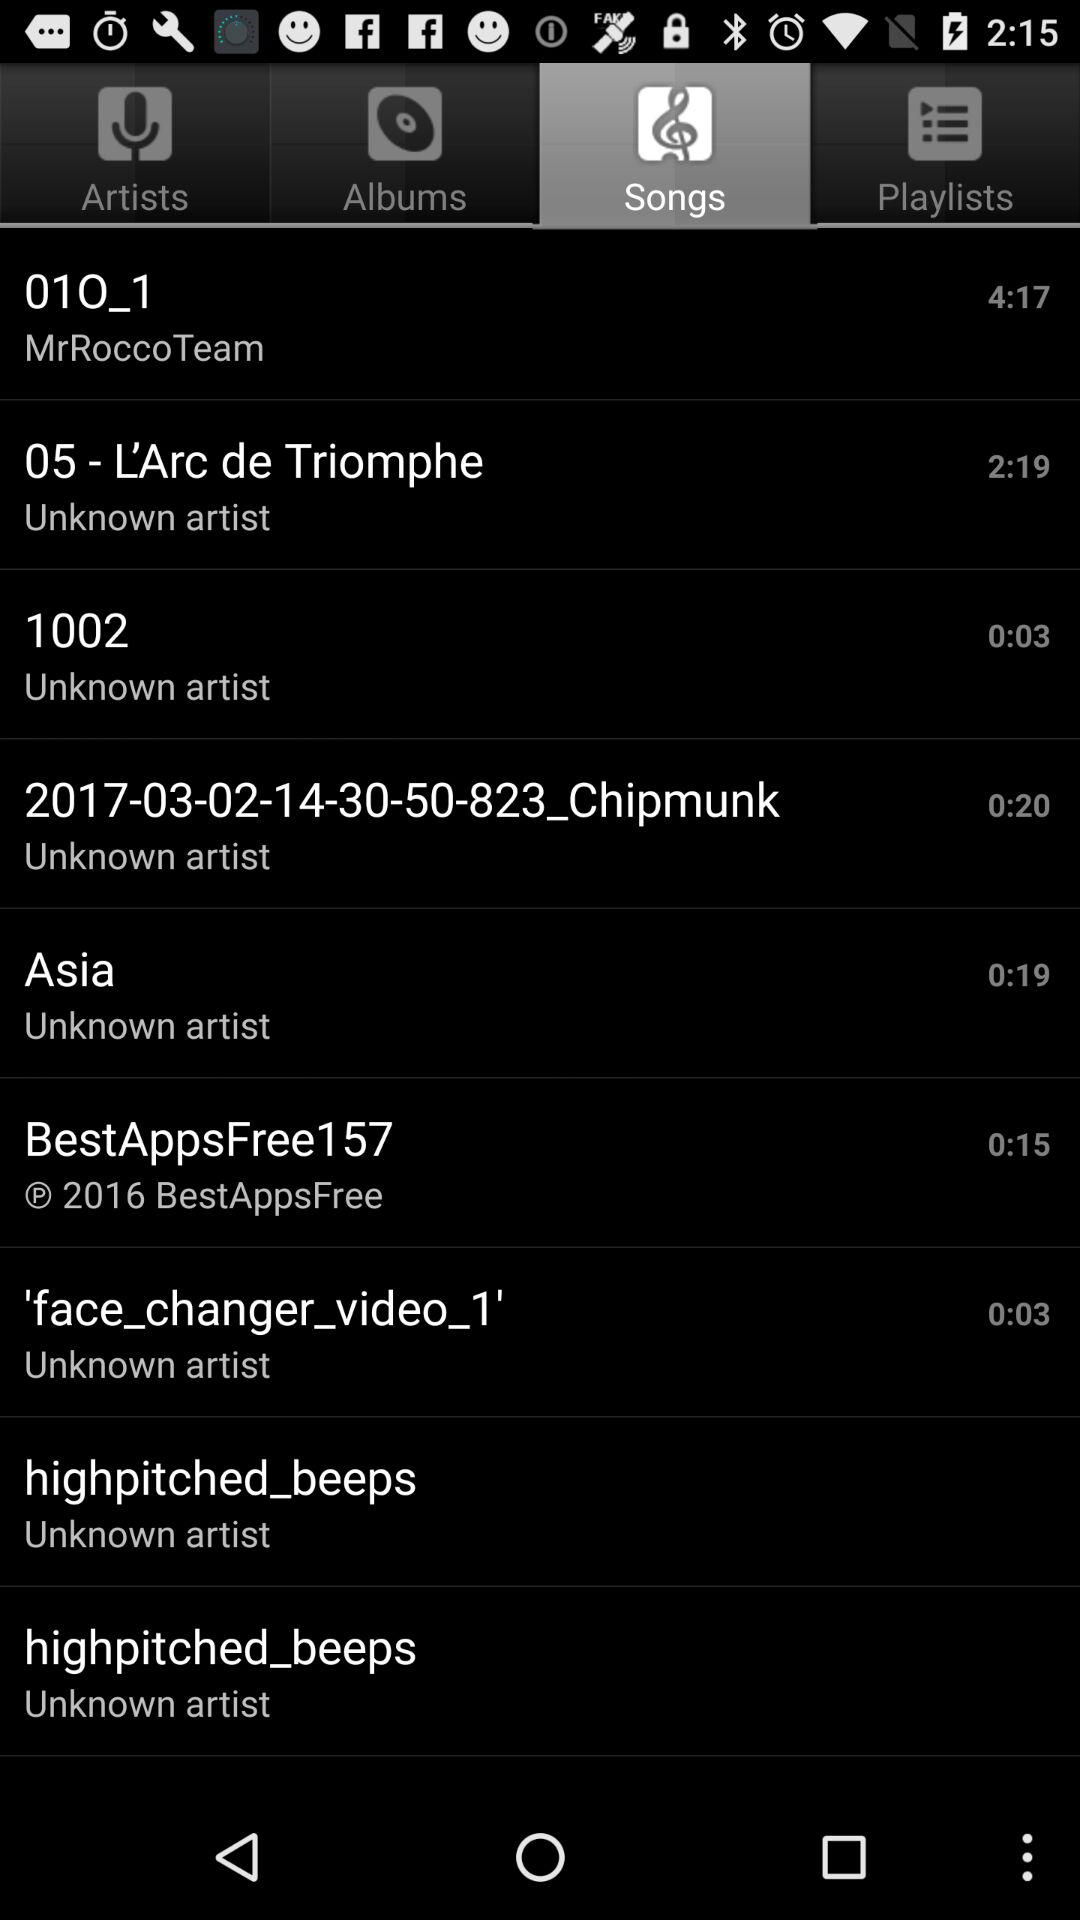Which song has the shortest duration time?
When the provided information is insufficient, respond with <no answer>. <no answer> 